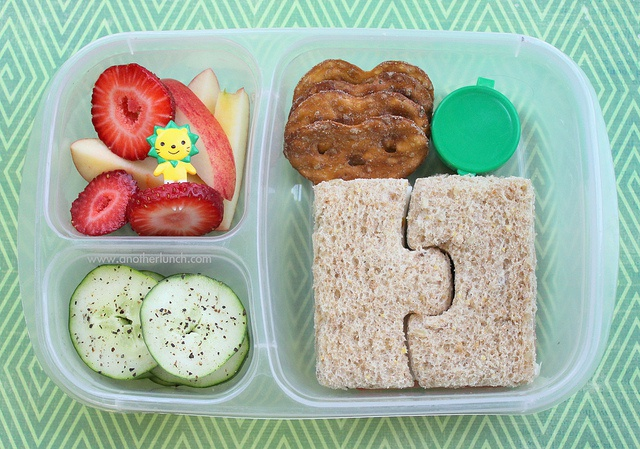Describe the objects in this image and their specific colors. I can see dining table in lightblue, darkgray, lightgray, turquoise, and tan tones, sandwich in turquoise, lightgray, tan, and darkgray tones, sandwich in turquoise, lightgray, tan, and darkgray tones, apple in turquoise, salmon, lightpink, and tan tones, and apple in turquoise, lightgray, and tan tones in this image. 